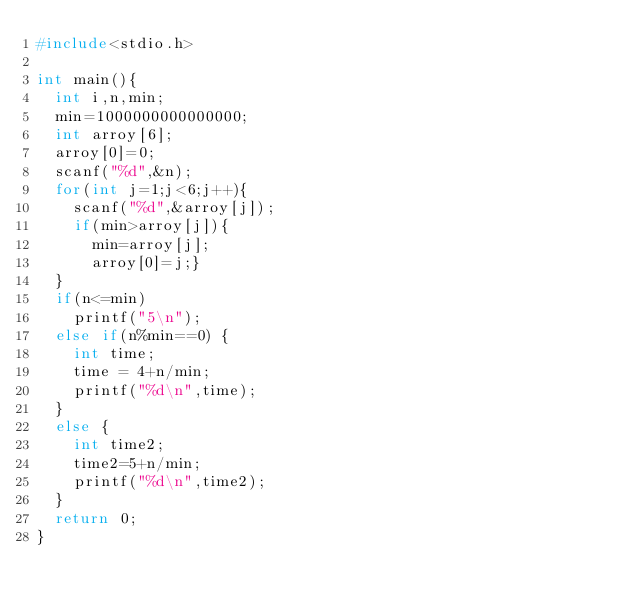<code> <loc_0><loc_0><loc_500><loc_500><_C_>#include<stdio.h>

int main(){
  int i,n,min;
  min=1000000000000000;
  int arroy[6];
  arroy[0]=0;
  scanf("%d",&n);
  for(int j=1;j<6;j++){
    scanf("%d",&arroy[j]);
    if(min>arroy[j]){
      min=arroy[j];
      arroy[0]=j;}
  }
  if(n<=min)
    printf("5\n");
  else if(n%min==0) {
    int time;
    time = 4+n/min;
    printf("%d\n",time);
  }
  else {
    int time2;
    time2=5+n/min;
    printf("%d\n",time2);
  }
  return 0;
}

    
</code> 